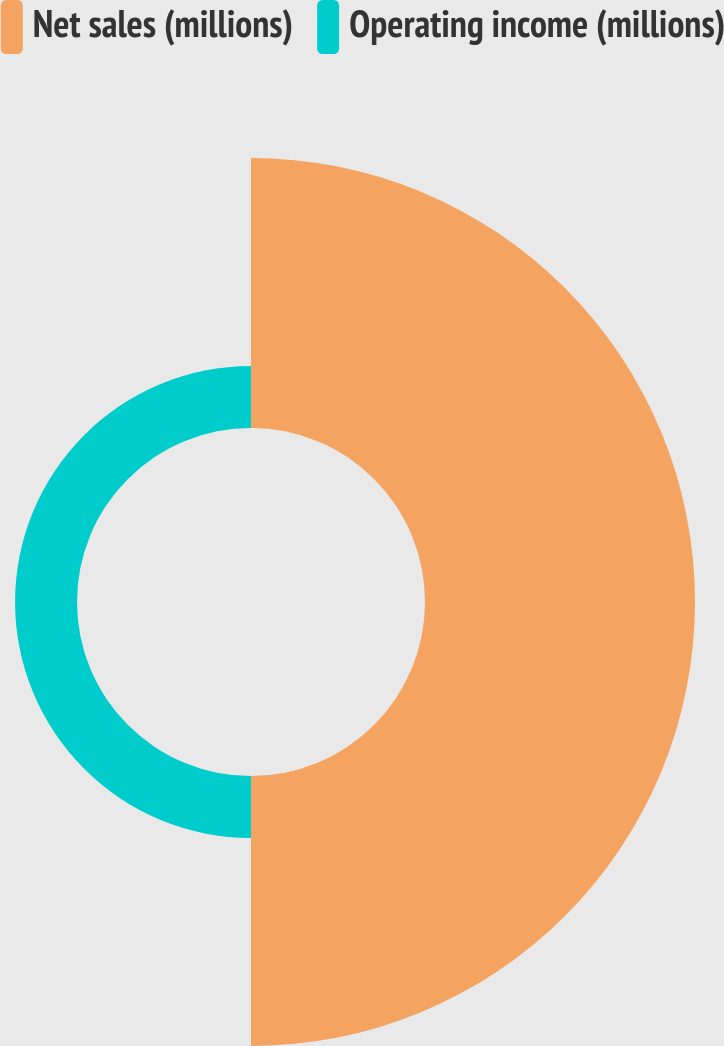Convert chart. <chart><loc_0><loc_0><loc_500><loc_500><pie_chart><fcel>Net sales (millions)<fcel>Operating income (millions)<nl><fcel>81.34%<fcel>18.66%<nl></chart> 